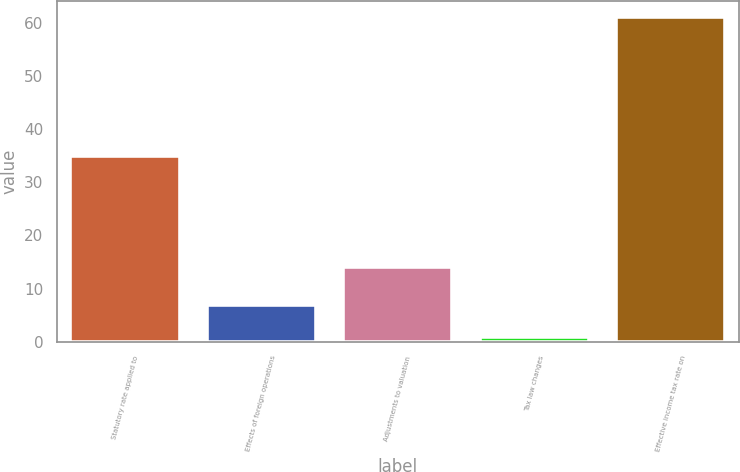Convert chart. <chart><loc_0><loc_0><loc_500><loc_500><bar_chart><fcel>Statutory rate applied to<fcel>Effects of foreign operations<fcel>Adjustments to valuation<fcel>Tax law changes<fcel>Effective income tax rate on<nl><fcel>35<fcel>7<fcel>14<fcel>1<fcel>61<nl></chart> 